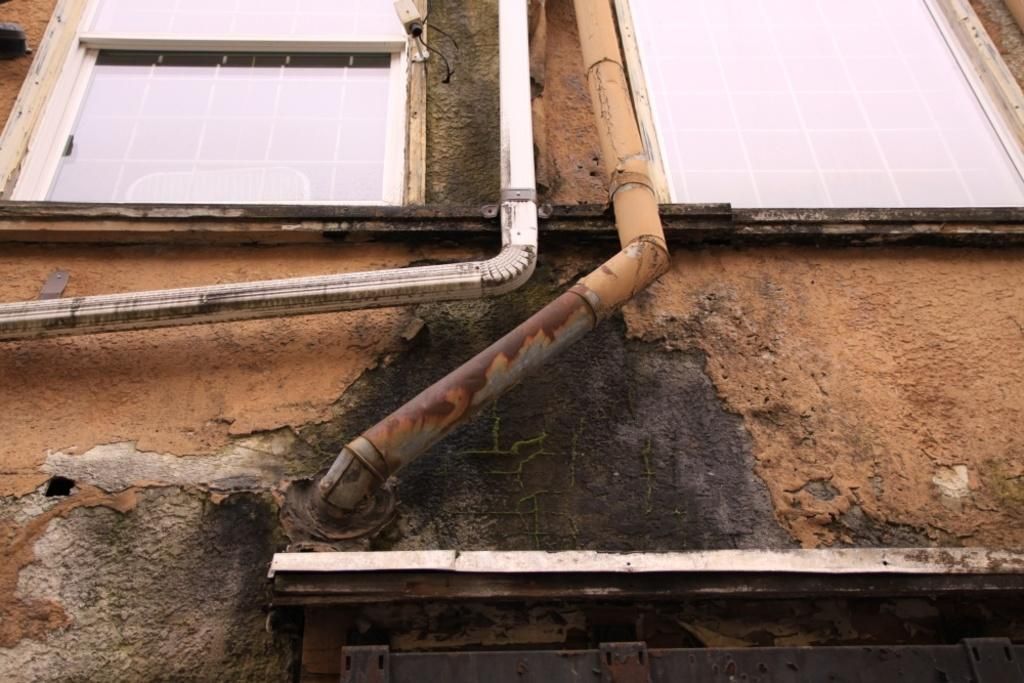What type of structure is visible in the image? There is a building in the image. Can you describe any specific features of the building? There are two pipes and glass windows on the building. Are there any additional objects or devices on the building? Yes, there is a camera on the walls of the building. Can you tell me how many cups are hanging from the pipes on the building? There are no cups present on the pipes in the image. Is there a swing attached to the building in the image? There is no swing visible in the image. 